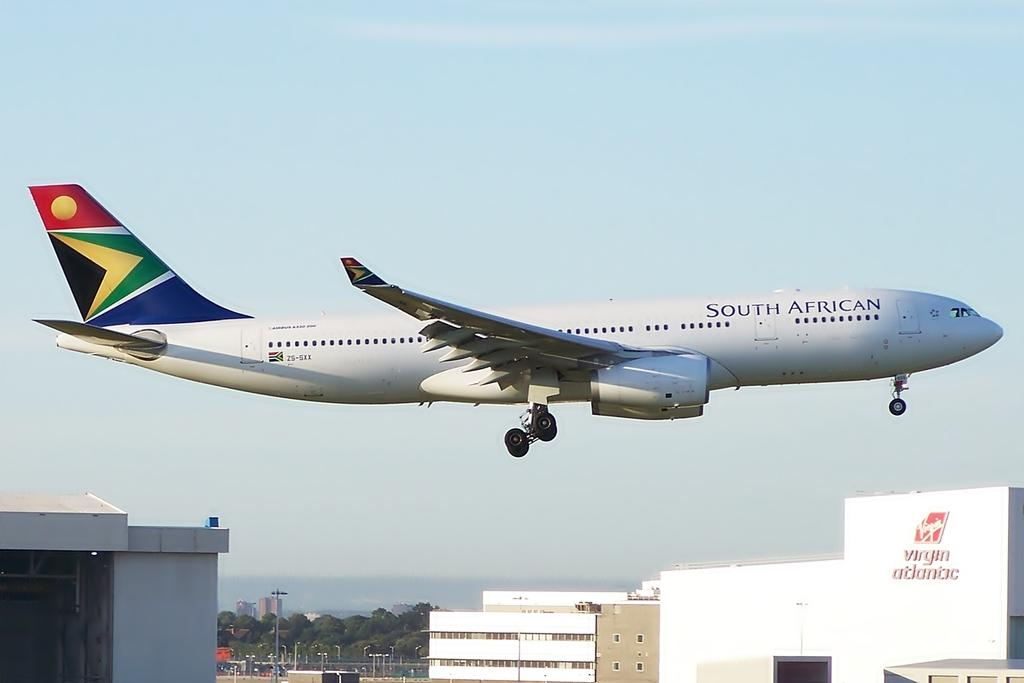What is flying in the air in the image? There is a plane flying in the air with wings in the image. What structures can be seen on the ground in the image? There are buildings visible in the image. What can be seen far in the distance in the image? Far in the distance, there are trees, buildings, and light poles. What part of the natural environment is visible in the image? The sky is visible in the background of the image. What type of sail can be seen on the plane in the image? There is no sail present on the plane in the image; it is an airplane with wings. Is there a gun visible in the image? There is no gun present in the image. 